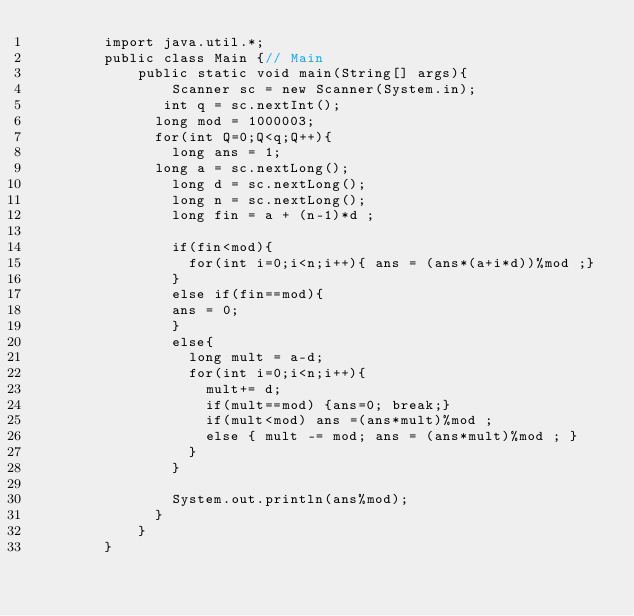Convert code to text. <code><loc_0><loc_0><loc_500><loc_500><_Java_>        import java.util.*;
        public class Main {// Main
            public static void main(String[] args){
                Scanner sc = new Scanner(System.in);
               int q = sc.nextInt();
              long mod = 1000003;
              for(int Q=0;Q<q;Q++){
                long ans = 1;
              long a = sc.nextLong();
                long d = sc.nextLong();
                long n = sc.nextLong();
                long fin = a + (n-1)*d ;
                
                if(fin<mod){
                  for(int i=0;i<n;i++){ ans = (ans*(a+i*d))%mod ;}
                }
                else if(fin==mod){
                ans = 0;
                }
                else{
                  long mult = a-d;
                  for(int i=0;i<n;i++){ 
                    mult+= d;
                    if(mult==mod) {ans=0; break;}
                    if(mult<mod) ans =(ans*mult)%mod ;
                    else { mult -= mod; ans = (ans*mult)%mod ; }
                  }
                }
                
                System.out.println(ans%mod);
              }
            }
        }							</code> 